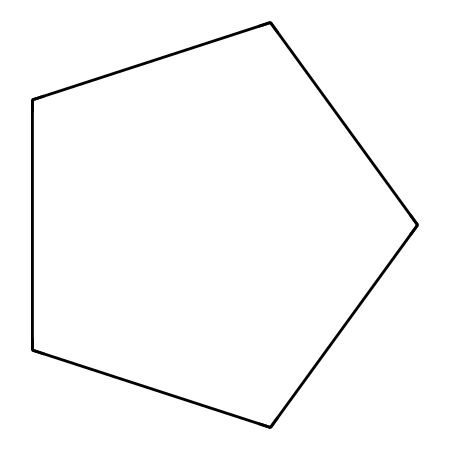What is the molecular formula of cyclopentane? The SMILES representation shows five carbon atoms (C) connected in a ring, each bonded to two hydrogen atoms (H), leading to the formula C5H10.
Answer: C5H10 How many carbon atoms are in cyclopentane? From the SMILES representation, we can see there are five "C" symbols, indicating five carbon atoms present in the structure.
Answer: 5 What type of compound is cyclopentane? Cyclopentane is classified as a cycloalkane due to its cyclic structure and carbon-only composition, fitting the criteria of cycloalkanes (saturated hydrocarbons with carbons arranged in a ring).
Answer: cycloalkane What type of hydrogen atoms are present in cyclopentane? The hydrogen atoms in cyclopentane are classified as saturated hydrogen as they are bonded to carbon atoms in a fully saturated manner, without any double or triple bonds present in the structure.
Answer: saturated What is the bond angle in cyclopentane? The bond angles in cyclopentane are approximately 108 degrees, influenced by the tetrahedral geometry of sp3 hybridized carbon atoms in a pentagonal arrangement.
Answer: 108 degrees Explain the stability of cyclopentane compared to larger cycloalkanes. Cyclopentane exhibits more strain relief compared to larger cycloalkanes due to its ability to deform slightly, which minimizes angle strain, unlike larger rings which can experience torsional strain due to strain in bond angles between carbons.
Answer: more stable How does the structure of cyclopentane affect its use in ship hull coatings? The cyclopentane structure provides flexibility and a low glass transition temperature, making it useful in coatings that require good adhesion and flexibility, which helps in resisting cracks and degradation in marine environments.
Answer: flexibility 